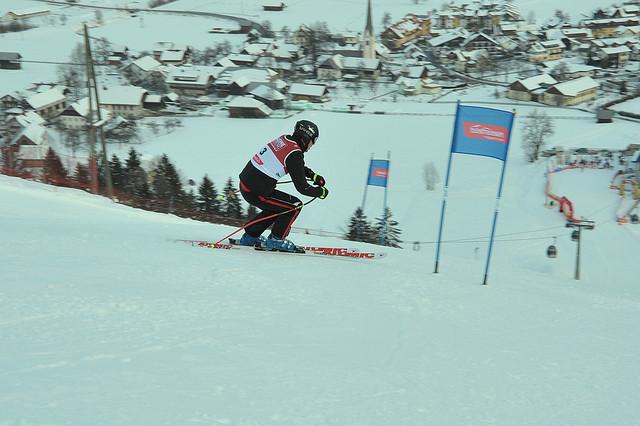Who is the sponsor?
Write a very short answer. Sign is blurry. What can be seen at the bottom of the hill?
Concise answer only. Houses. How many poles?
Keep it brief. 2. What color are his shoes?
Concise answer only. Blue. What is the purpose of the tall pole in the back left?
Concise answer only. Cell tower. What is the accent color on the blue sign?
Write a very short answer. Red. What is the person doing?
Write a very short answer. Skiing. What color are most of the flags?
Be succinct. Blue. What is the name of the ski trail?
Short answer required. Alpine. Can you see grass?
Short answer required. No. 